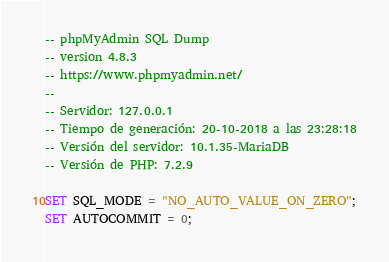<code> <loc_0><loc_0><loc_500><loc_500><_SQL_>-- phpMyAdmin SQL Dump
-- version 4.8.3
-- https://www.phpmyadmin.net/
--
-- Servidor: 127.0.0.1
-- Tiempo de generación: 20-10-2018 a las 23:28:18
-- Versión del servidor: 10.1.35-MariaDB
-- Versión de PHP: 7.2.9

SET SQL_MODE = "NO_AUTO_VALUE_ON_ZERO";
SET AUTOCOMMIT = 0;</code> 